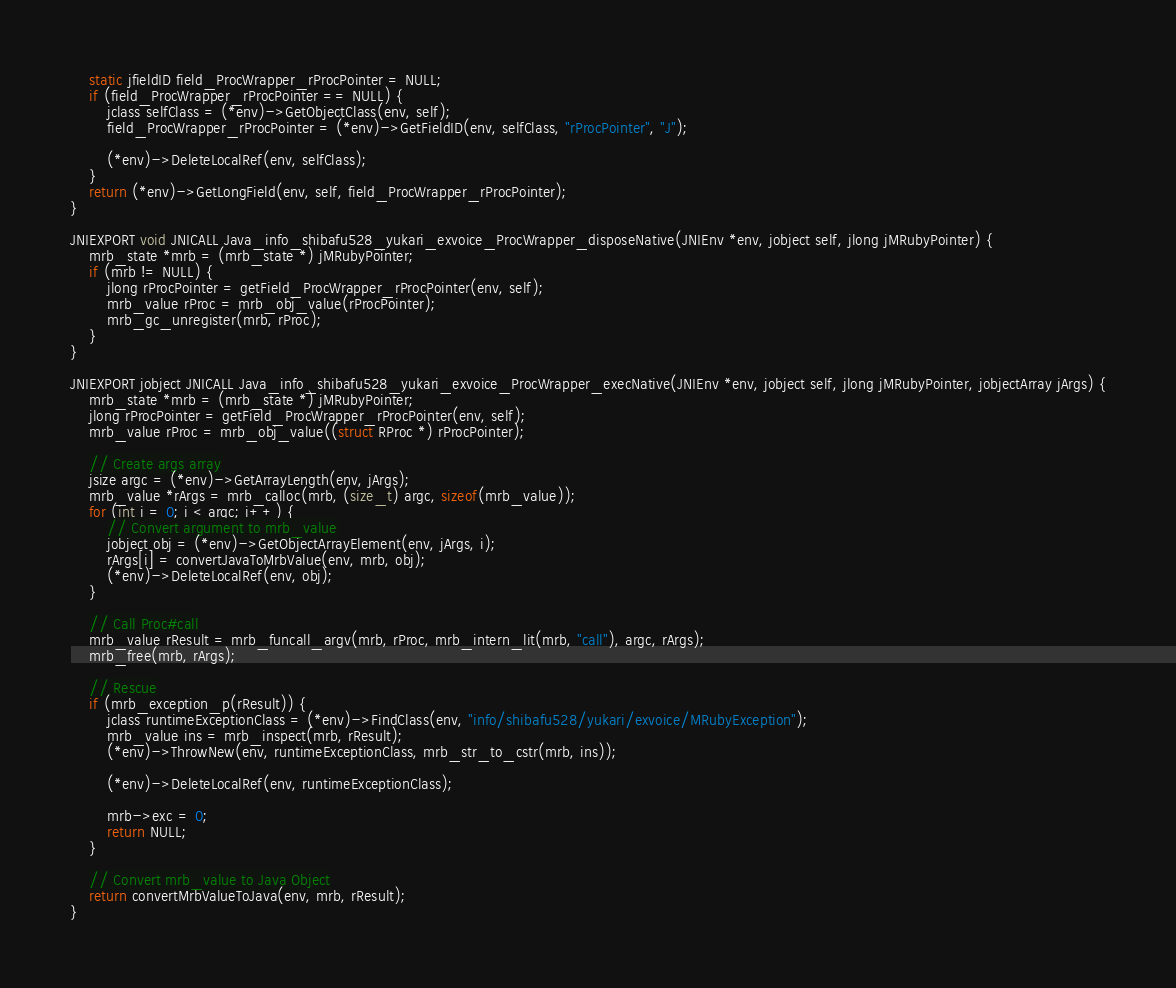<code> <loc_0><loc_0><loc_500><loc_500><_C_>    static jfieldID field_ProcWrapper_rProcPointer = NULL;
    if (field_ProcWrapper_rProcPointer == NULL) {
        jclass selfClass = (*env)->GetObjectClass(env, self);
        field_ProcWrapper_rProcPointer = (*env)->GetFieldID(env, selfClass, "rProcPointer", "J");

        (*env)->DeleteLocalRef(env, selfClass);
    }
    return (*env)->GetLongField(env, self, field_ProcWrapper_rProcPointer);
}

JNIEXPORT void JNICALL Java_info_shibafu528_yukari_exvoice_ProcWrapper_disposeNative(JNIEnv *env, jobject self, jlong jMRubyPointer) {
    mrb_state *mrb = (mrb_state *) jMRubyPointer;
    if (mrb != NULL) {
        jlong rProcPointer = getField_ProcWrapper_rProcPointer(env, self);
        mrb_value rProc = mrb_obj_value(rProcPointer);
        mrb_gc_unregister(mrb, rProc);
    }
}

JNIEXPORT jobject JNICALL Java_info_shibafu528_yukari_exvoice_ProcWrapper_execNative(JNIEnv *env, jobject self, jlong jMRubyPointer, jobjectArray jArgs) {
    mrb_state *mrb = (mrb_state *) jMRubyPointer;
    jlong rProcPointer = getField_ProcWrapper_rProcPointer(env, self);
    mrb_value rProc = mrb_obj_value((struct RProc *) rProcPointer);

    // Create args array
    jsize argc = (*env)->GetArrayLength(env, jArgs);
    mrb_value *rArgs = mrb_calloc(mrb, (size_t) argc, sizeof(mrb_value));
    for (int i = 0; i < argc; i++) {
        // Convert argument to mrb_value
        jobject obj = (*env)->GetObjectArrayElement(env, jArgs, i);
        rArgs[i] = convertJavaToMrbValue(env, mrb, obj);
        (*env)->DeleteLocalRef(env, obj);
    }

    // Call Proc#call
    mrb_value rResult = mrb_funcall_argv(mrb, rProc, mrb_intern_lit(mrb, "call"), argc, rArgs);
    mrb_free(mrb, rArgs);

    // Rescue
    if (mrb_exception_p(rResult)) {
        jclass runtimeExceptionClass = (*env)->FindClass(env, "info/shibafu528/yukari/exvoice/MRubyException");
        mrb_value ins = mrb_inspect(mrb, rResult);
        (*env)->ThrowNew(env, runtimeExceptionClass, mrb_str_to_cstr(mrb, ins));

        (*env)->DeleteLocalRef(env, runtimeExceptionClass);

        mrb->exc = 0;
        return NULL;
    }

    // Convert mrb_value to Java Object
    return convertMrbValueToJava(env, mrb, rResult);
}</code> 